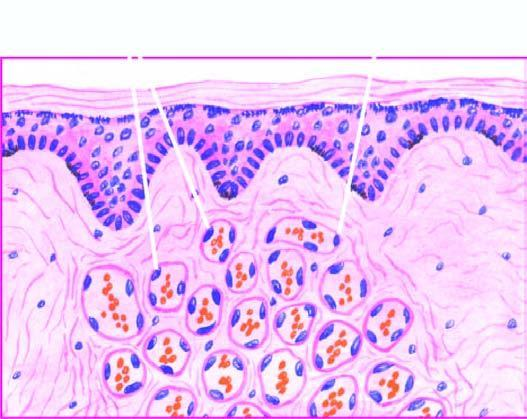does thickness and intensity of colour of arrow on left side of figure consist of scant connective tissue?
Answer the question using a single word or phrase. No 